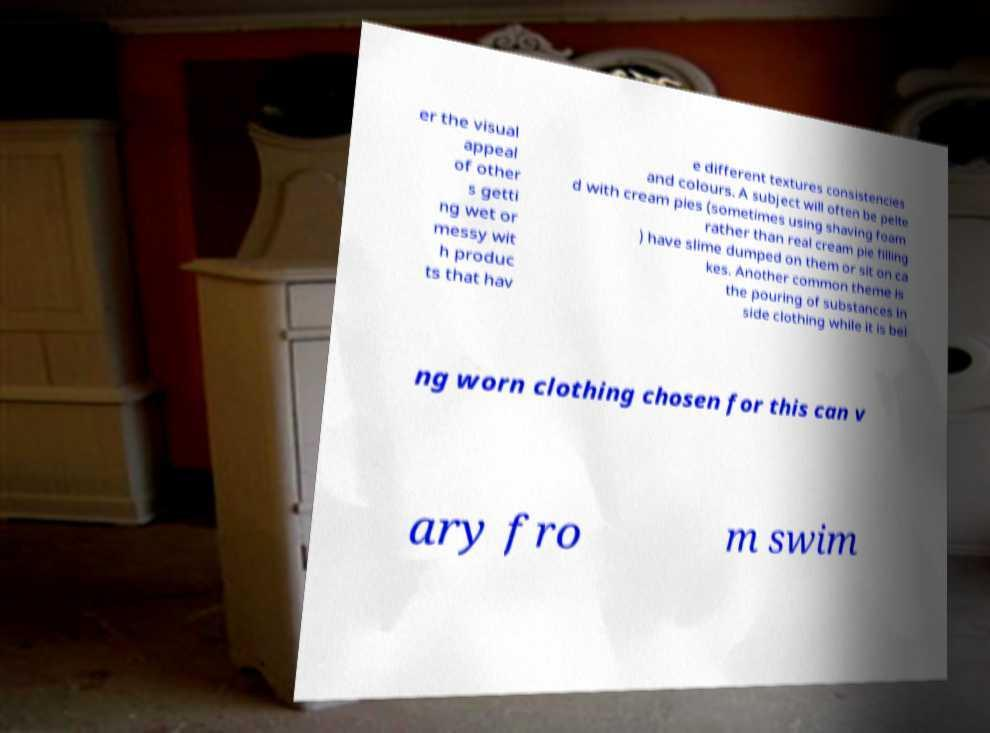Please read and relay the text visible in this image. What does it say? er the visual appeal of other s getti ng wet or messy wit h produc ts that hav e different textures consistencies and colours. A subject will often be pelte d with cream pies (sometimes using shaving foam rather than real cream pie filling ) have slime dumped on them or sit on ca kes. Another common theme is the pouring of substances in side clothing while it is bei ng worn clothing chosen for this can v ary fro m swim 